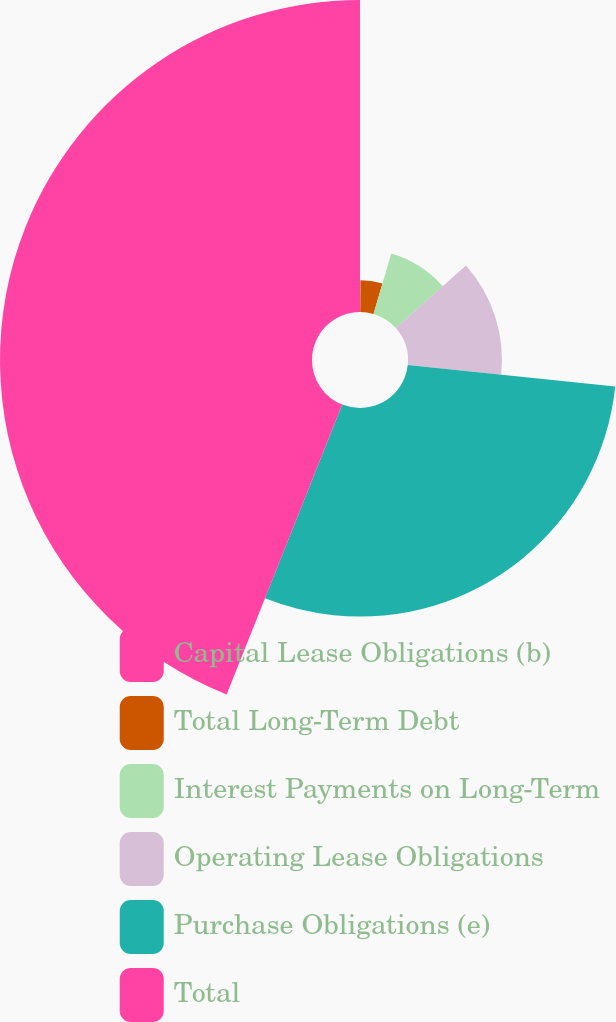Convert chart to OTSL. <chart><loc_0><loc_0><loc_500><loc_500><pie_chart><fcel>Capital Lease Obligations (b)<fcel>Total Long-Term Debt<fcel>Interest Payments on Long-Term<fcel>Operating Lease Obligations<fcel>Purchase Obligations (e)<fcel>Total<nl><fcel>0.08%<fcel>4.47%<fcel>8.86%<fcel>13.24%<fcel>29.39%<fcel>43.96%<nl></chart> 